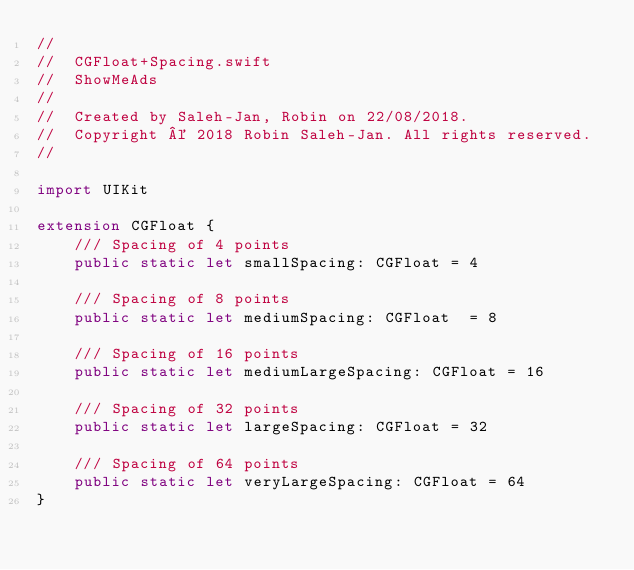<code> <loc_0><loc_0><loc_500><loc_500><_Swift_>//
//  CGFloat+Spacing.swift
//  ShowMeAds
//
//  Created by Saleh-Jan, Robin on 22/08/2018.
//  Copyright © 2018 Robin Saleh-Jan. All rights reserved.
//

import UIKit

extension CGFloat {
    /// Spacing of 4 points
    public static let smallSpacing: CGFloat = 4
    
    /// Spacing of 8 points
    public static let mediumSpacing: CGFloat  = 8
    
    /// Spacing of 16 points
    public static let mediumLargeSpacing: CGFloat = 16
    
    /// Spacing of 32 points
    public static let largeSpacing: CGFloat = 32
    
    /// Spacing of 64 points
    public static let veryLargeSpacing: CGFloat = 64
}
</code> 